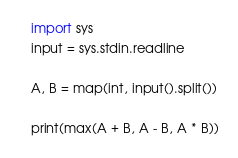Convert code to text. <code><loc_0><loc_0><loc_500><loc_500><_Python_>import sys
input = sys.stdin.readline

A, B = map(int, input().split())

print(max(A + B, A - B, A * B))</code> 